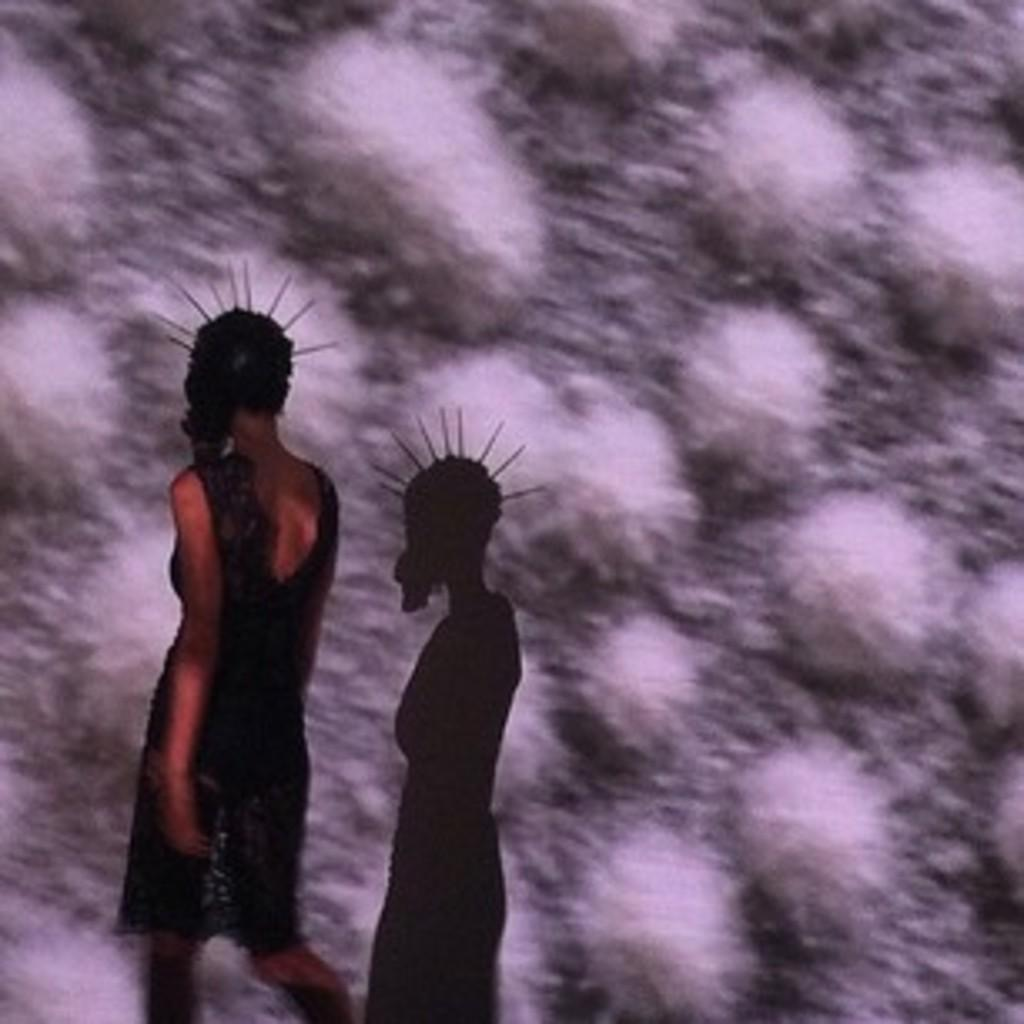Who is present in the image? There is a woman in the image. What can be seen in front of the woman? There is a shadow in front of the woman. How many kittens are playing with the duck in the image? There are no kittens or ducks present in the image; it only features a woman and a shadow. 